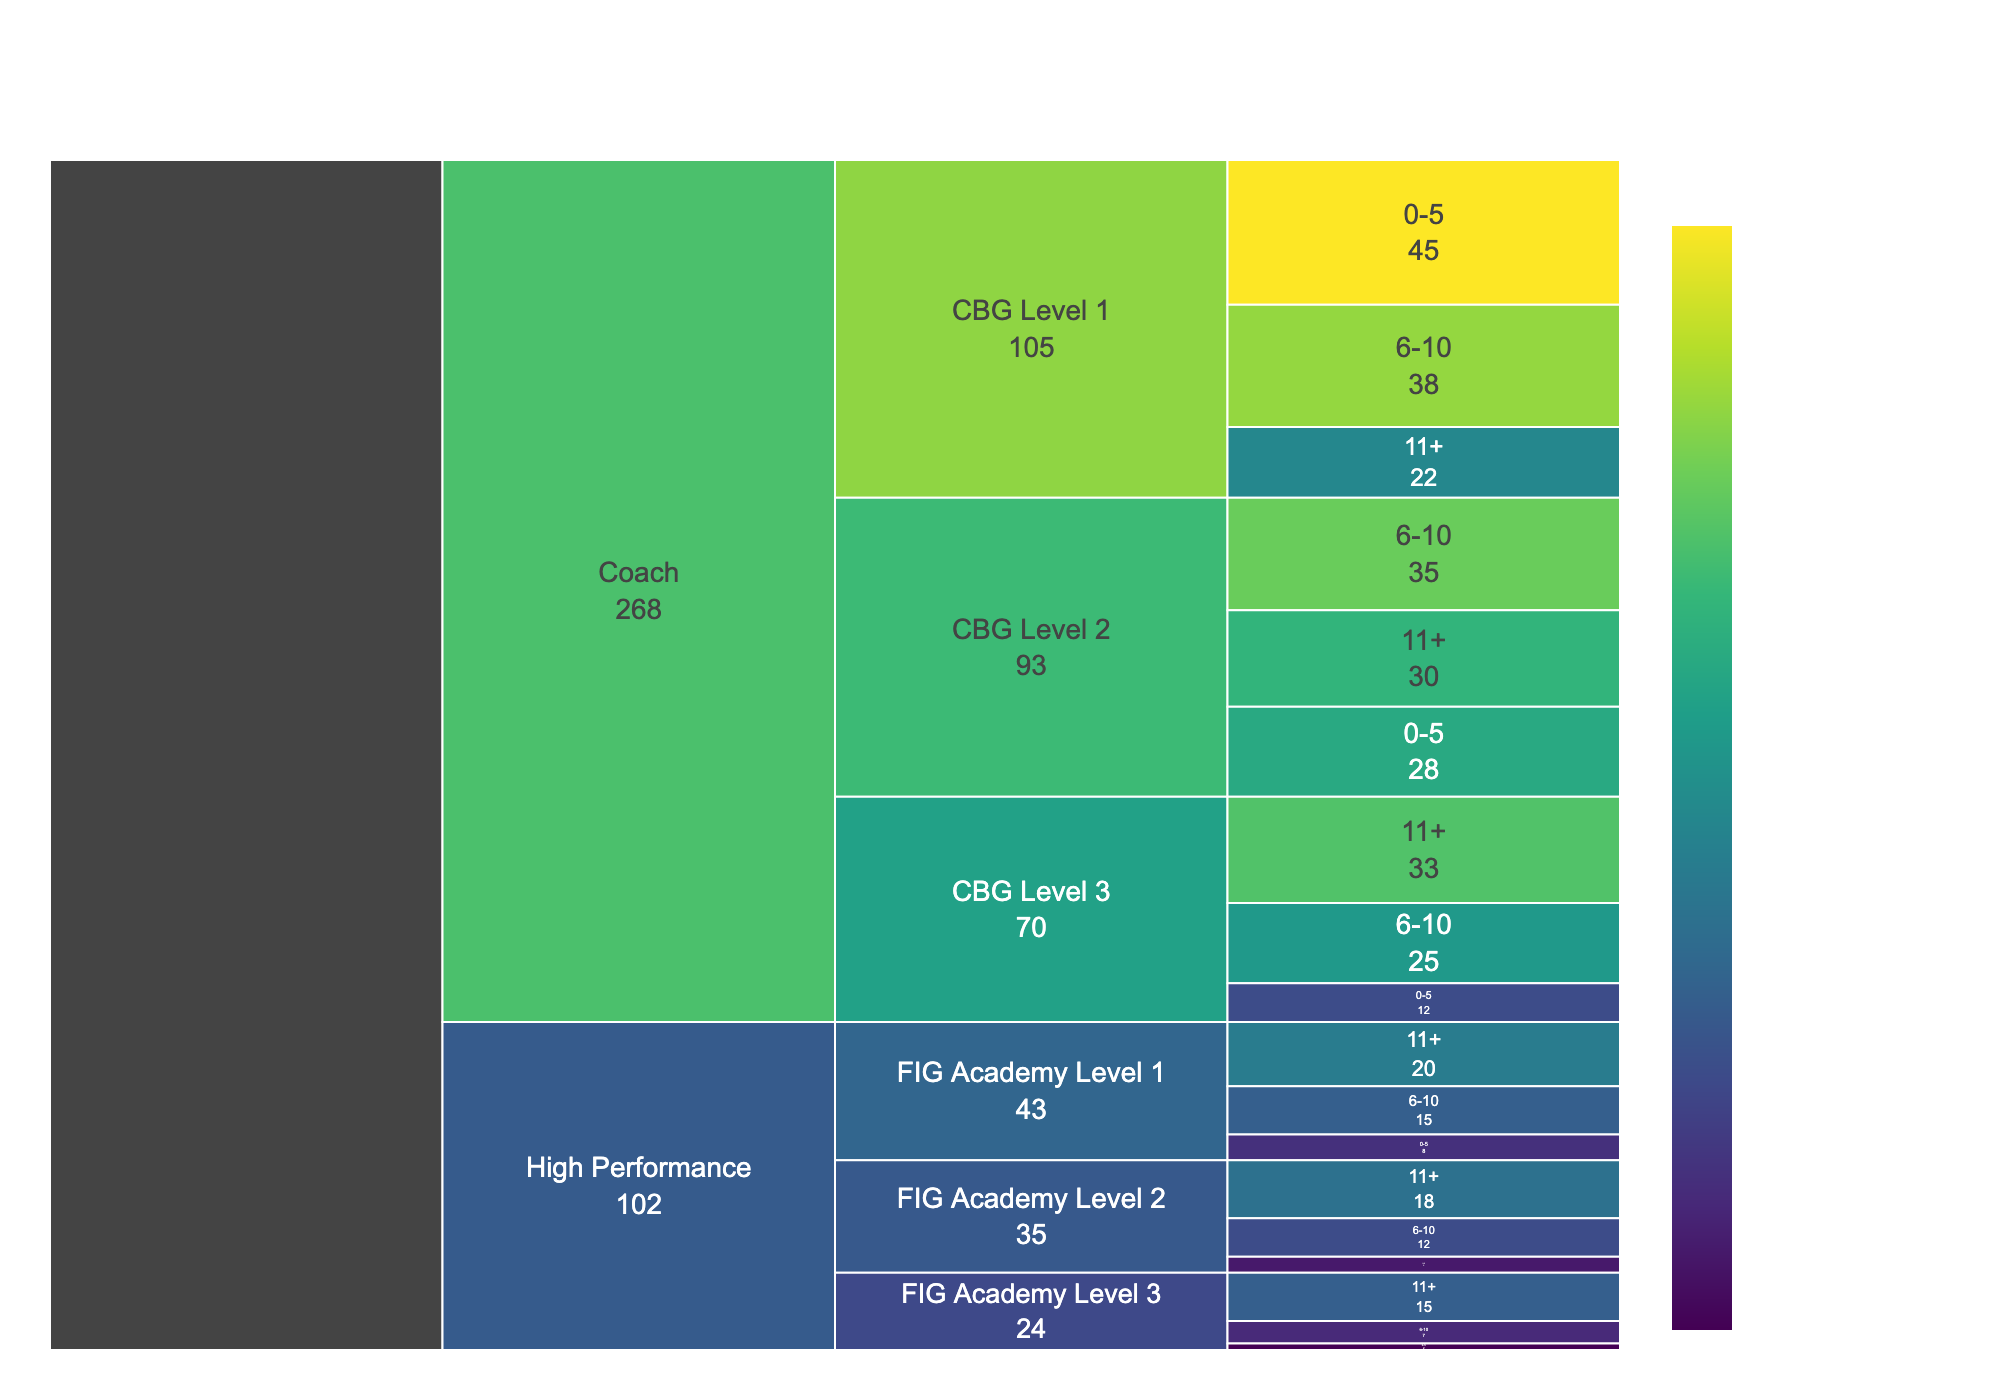What is the title of the chart? The title of the chart is prominently displayed at the top, providing an overview of the chart's purpose.
Answer: Career Progression of Brazilian Gymnastics Coaches Which group has the highest number of coaches with 0-5 years of experience? To find this, look at the color and numeric value associated with the "0-5 years" category for each certification level. The group with the highest number is the one with the darkest color and largest number.
Answer: Coach, CBG Level 1 How many coaches have more than 10 years of experience across all levels? Add the values corresponding to "11+" years of experience for each certification level. Steps: 22 (CBG Level 1) + 30 (CBG Level 2) + 33 (CBG Level 3) + 20 (FIG Academy Level 1) + 18 (FIG Academy Level 2) + 15 (FIG Academy Level 3).
Answer: 138 Which level has the fewest coaches in the 6-10 years of experience category? Compare the number of coaches for each level in the "6-10 years" category. The level with the smallest number is the answer.
Answer: High Performance, FIG Academy Level 3 What is the total number of coaches in the High Performance level? Sum all the counts under the High Performance level. Steps: Add the counts for FIG Academy Level 1 (43), FIG Academy Level 2 (35), and FIG Academy Level 3 (24).
Answer: 102 How does the number of coaches with CBG Level 2 certification and 11+ years of experience compare to those with FIG Academy Level 1 certification and 11+ years of experience? Look at the counts for these two specific categories and compare their values.
Answer: 30 vs. 20 What percentage of coaches with FIG Academy Level 2 certification have 0-5 years of experience? First, find the total number of FIG Academy Level 2 certified coaches, then calculate the percentage that has 0-5 years. Steps: Total = 5 (0-5 years) + 12 (6-10 years) + 18 (11+ years) = 35. Percentage = (5/35) * 100.
Answer: 14.29% Which category within the Coach level has the most evenly distributed experience years? Compare the distribution of counts across the three experience categories for each certification within the Coach level. The most evenly distributed will have similar numbers across all three categories.
Answer: CBG Level 2 What is the sum of coaches with CBG Level 1 and 6-10 years of experience and coaches with FIG Academy Level 3 and 11+ years of experience? Add together the counts for these specific categories: 38 (CBG Level 1, 6-10 years) + 15 (FIG Academy Level 3, 11+ years).
Answer: 53 